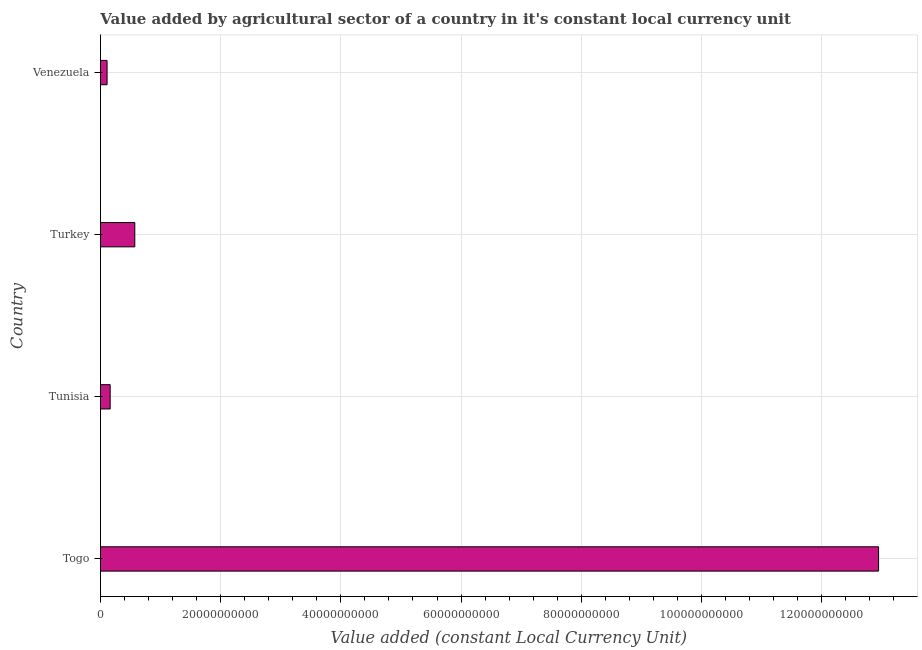Does the graph contain any zero values?
Ensure brevity in your answer.  No. Does the graph contain grids?
Your answer should be very brief. Yes. What is the title of the graph?
Ensure brevity in your answer.  Value added by agricultural sector of a country in it's constant local currency unit. What is the label or title of the X-axis?
Give a very brief answer. Value added (constant Local Currency Unit). What is the label or title of the Y-axis?
Your response must be concise. Country. What is the value added by agriculture sector in Turkey?
Ensure brevity in your answer.  5.72e+09. Across all countries, what is the maximum value added by agriculture sector?
Give a very brief answer. 1.29e+11. Across all countries, what is the minimum value added by agriculture sector?
Make the answer very short. 1.11e+09. In which country was the value added by agriculture sector maximum?
Your answer should be very brief. Togo. In which country was the value added by agriculture sector minimum?
Make the answer very short. Venezuela. What is the sum of the value added by agriculture sector?
Ensure brevity in your answer.  1.38e+11. What is the difference between the value added by agriculture sector in Turkey and Venezuela?
Your answer should be compact. 4.61e+09. What is the average value added by agriculture sector per country?
Your response must be concise. 3.45e+1. What is the median value added by agriculture sector?
Ensure brevity in your answer.  3.67e+09. In how many countries, is the value added by agriculture sector greater than 72000000000 LCU?
Provide a short and direct response. 1. What is the ratio of the value added by agriculture sector in Turkey to that in Venezuela?
Your answer should be very brief. 5.16. What is the difference between the highest and the second highest value added by agriculture sector?
Offer a terse response. 1.24e+11. Is the sum of the value added by agriculture sector in Togo and Turkey greater than the maximum value added by agriculture sector across all countries?
Offer a very short reply. Yes. What is the difference between the highest and the lowest value added by agriculture sector?
Keep it short and to the point. 1.28e+11. How many bars are there?
Your answer should be compact. 4. How many countries are there in the graph?
Make the answer very short. 4. What is the difference between two consecutive major ticks on the X-axis?
Offer a very short reply. 2.00e+1. What is the Value added (constant Local Currency Unit) of Togo?
Your answer should be compact. 1.29e+11. What is the Value added (constant Local Currency Unit) in Tunisia?
Provide a short and direct response. 1.62e+09. What is the Value added (constant Local Currency Unit) in Turkey?
Your answer should be compact. 5.72e+09. What is the Value added (constant Local Currency Unit) of Venezuela?
Ensure brevity in your answer.  1.11e+09. What is the difference between the Value added (constant Local Currency Unit) in Togo and Tunisia?
Your response must be concise. 1.28e+11. What is the difference between the Value added (constant Local Currency Unit) in Togo and Turkey?
Your response must be concise. 1.24e+11. What is the difference between the Value added (constant Local Currency Unit) in Togo and Venezuela?
Make the answer very short. 1.28e+11. What is the difference between the Value added (constant Local Currency Unit) in Tunisia and Turkey?
Provide a short and direct response. -4.10e+09. What is the difference between the Value added (constant Local Currency Unit) in Tunisia and Venezuela?
Offer a terse response. 5.14e+08. What is the difference between the Value added (constant Local Currency Unit) in Turkey and Venezuela?
Offer a very short reply. 4.61e+09. What is the ratio of the Value added (constant Local Currency Unit) in Togo to that in Tunisia?
Offer a very short reply. 79.85. What is the ratio of the Value added (constant Local Currency Unit) in Togo to that in Turkey?
Provide a succinct answer. 22.63. What is the ratio of the Value added (constant Local Currency Unit) in Togo to that in Venezuela?
Your answer should be very brief. 116.89. What is the ratio of the Value added (constant Local Currency Unit) in Tunisia to that in Turkey?
Ensure brevity in your answer.  0.28. What is the ratio of the Value added (constant Local Currency Unit) in Tunisia to that in Venezuela?
Your response must be concise. 1.46. What is the ratio of the Value added (constant Local Currency Unit) in Turkey to that in Venezuela?
Your answer should be compact. 5.16. 